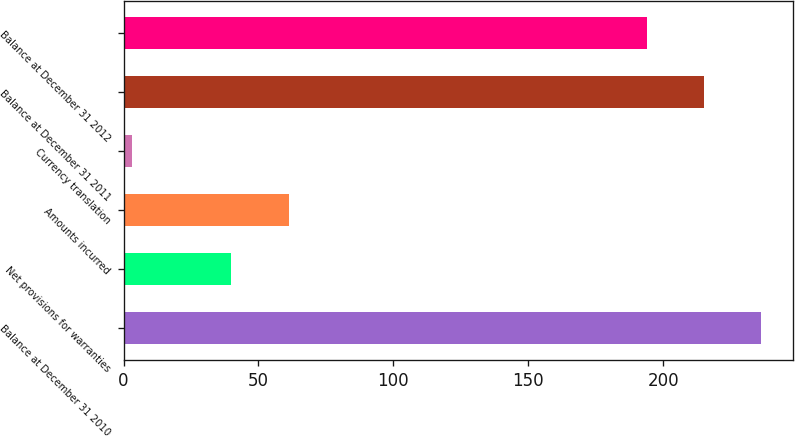<chart> <loc_0><loc_0><loc_500><loc_500><bar_chart><fcel>Balance at December 31 2010<fcel>Net provisions for warranties<fcel>Amounts incurred<fcel>Currency translation<fcel>Balance at December 31 2011<fcel>Balance at December 31 2012<nl><fcel>236.4<fcel>40<fcel>61.2<fcel>3<fcel>215.2<fcel>194<nl></chart> 